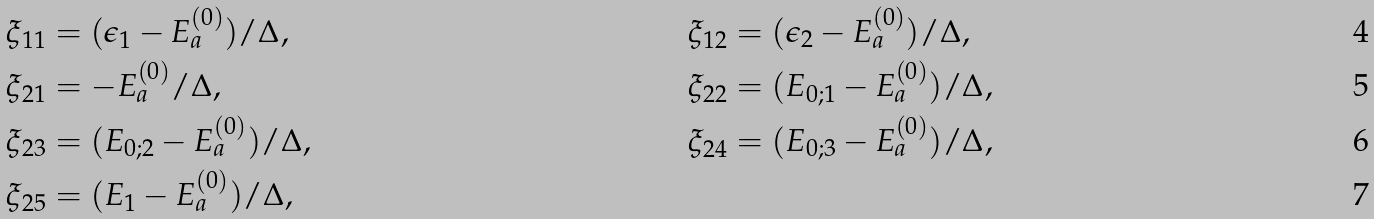Convert formula to latex. <formula><loc_0><loc_0><loc_500><loc_500>\xi _ { 1 1 } & = ( \epsilon _ { 1 } - E _ { a } ^ { ( 0 ) } ) / \Delta , & \xi _ { 1 2 } & = ( \epsilon _ { 2 } - E _ { a } ^ { ( 0 ) } ) / \Delta , \\ \xi _ { 2 1 } & = - E _ { a } ^ { ( 0 ) } / \Delta , & \xi _ { 2 2 } & = ( E _ { 0 ; 1 } - E _ { a } ^ { ( 0 ) } ) / \Delta , \\ \xi _ { 2 3 } & = ( E _ { 0 ; 2 } - E _ { a } ^ { ( 0 ) } ) / \Delta , & \xi _ { 2 4 } & = ( E _ { 0 ; 3 } - E _ { a } ^ { ( 0 ) } ) / \Delta , \\ \xi _ { 2 5 } & = ( E _ { 1 } - E _ { a } ^ { ( 0 ) } ) / \Delta ,</formula> 